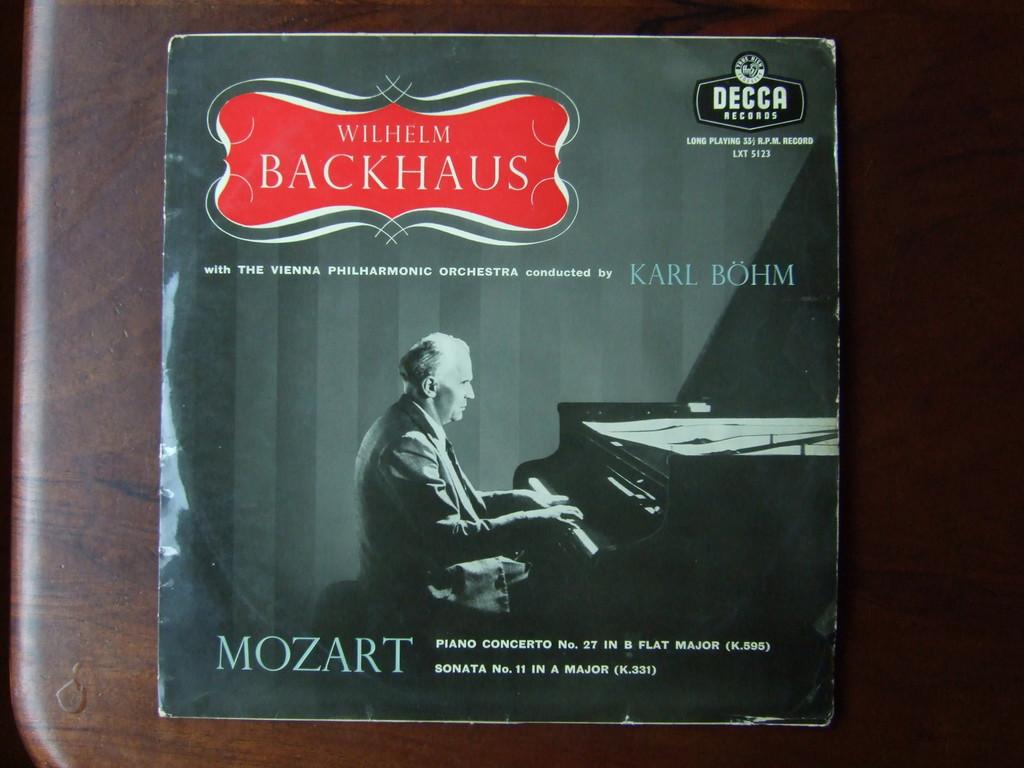Who was the conductor?
Keep it short and to the point. Karl bohm. 